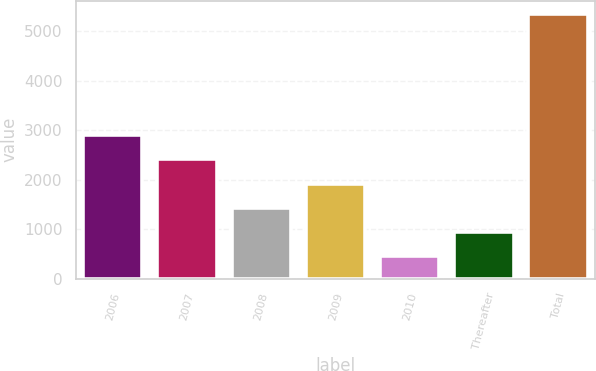Convert chart to OTSL. <chart><loc_0><loc_0><loc_500><loc_500><bar_chart><fcel>2006<fcel>2007<fcel>2008<fcel>2009<fcel>2010<fcel>Thereafter<fcel>Total<nl><fcel>2904<fcel>2414.2<fcel>1434.6<fcel>1924.4<fcel>455<fcel>944.8<fcel>5353<nl></chart> 